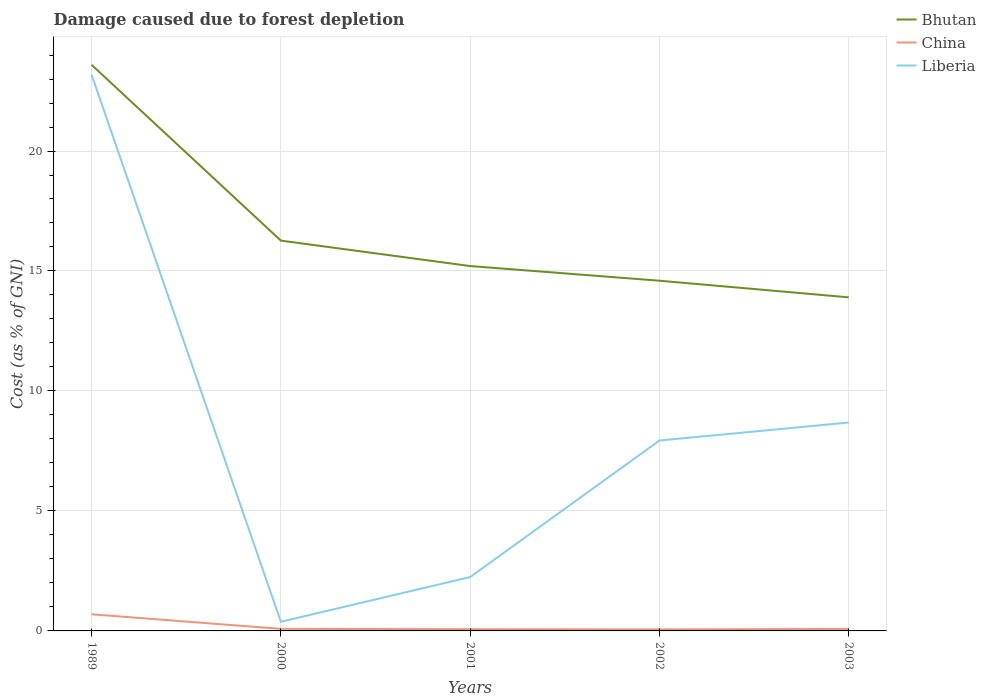Is the number of lines equal to the number of legend labels?
Keep it short and to the point. Yes. Across all years, what is the maximum cost of damage caused due to forest depletion in China?
Give a very brief answer. 0.06. What is the total cost of damage caused due to forest depletion in Liberia in the graph?
Your answer should be very brief. -0.75. What is the difference between the highest and the second highest cost of damage caused due to forest depletion in China?
Your answer should be compact. 0.63. How many lines are there?
Your answer should be very brief. 3. How many years are there in the graph?
Offer a terse response. 5. What is the difference between two consecutive major ticks on the Y-axis?
Provide a short and direct response. 5. Are the values on the major ticks of Y-axis written in scientific E-notation?
Your answer should be compact. No. Does the graph contain any zero values?
Ensure brevity in your answer.  No. How many legend labels are there?
Keep it short and to the point. 3. How are the legend labels stacked?
Provide a short and direct response. Vertical. What is the title of the graph?
Make the answer very short. Damage caused due to forest depletion. Does "Greece" appear as one of the legend labels in the graph?
Your response must be concise. No. What is the label or title of the Y-axis?
Your response must be concise. Cost (as % of GNI). What is the Cost (as % of GNI) in Bhutan in 1989?
Make the answer very short. 23.59. What is the Cost (as % of GNI) in China in 1989?
Make the answer very short. 0.69. What is the Cost (as % of GNI) in Liberia in 1989?
Your answer should be compact. 23.18. What is the Cost (as % of GNI) in Bhutan in 2000?
Provide a succinct answer. 16.27. What is the Cost (as % of GNI) in China in 2000?
Keep it short and to the point. 0.09. What is the Cost (as % of GNI) in Liberia in 2000?
Offer a very short reply. 0.38. What is the Cost (as % of GNI) of Bhutan in 2001?
Offer a very short reply. 15.21. What is the Cost (as % of GNI) of China in 2001?
Your response must be concise. 0.07. What is the Cost (as % of GNI) of Liberia in 2001?
Your answer should be compact. 2.24. What is the Cost (as % of GNI) of Bhutan in 2002?
Offer a very short reply. 14.59. What is the Cost (as % of GNI) of China in 2002?
Ensure brevity in your answer.  0.06. What is the Cost (as % of GNI) of Liberia in 2002?
Keep it short and to the point. 7.94. What is the Cost (as % of GNI) in Bhutan in 2003?
Make the answer very short. 13.9. What is the Cost (as % of GNI) in China in 2003?
Make the answer very short. 0.08. What is the Cost (as % of GNI) in Liberia in 2003?
Offer a very short reply. 8.68. Across all years, what is the maximum Cost (as % of GNI) in Bhutan?
Give a very brief answer. 23.59. Across all years, what is the maximum Cost (as % of GNI) in China?
Your answer should be compact. 0.69. Across all years, what is the maximum Cost (as % of GNI) of Liberia?
Give a very brief answer. 23.18. Across all years, what is the minimum Cost (as % of GNI) of Bhutan?
Offer a very short reply. 13.9. Across all years, what is the minimum Cost (as % of GNI) in China?
Give a very brief answer. 0.06. Across all years, what is the minimum Cost (as % of GNI) in Liberia?
Keep it short and to the point. 0.38. What is the total Cost (as % of GNI) of Bhutan in the graph?
Ensure brevity in your answer.  83.56. What is the total Cost (as % of GNI) in China in the graph?
Your answer should be very brief. 1. What is the total Cost (as % of GNI) in Liberia in the graph?
Your answer should be very brief. 42.43. What is the difference between the Cost (as % of GNI) of Bhutan in 1989 and that in 2000?
Your answer should be very brief. 7.33. What is the difference between the Cost (as % of GNI) in China in 1989 and that in 2000?
Your response must be concise. 0.61. What is the difference between the Cost (as % of GNI) of Liberia in 1989 and that in 2000?
Ensure brevity in your answer.  22.8. What is the difference between the Cost (as % of GNI) of Bhutan in 1989 and that in 2001?
Make the answer very short. 8.39. What is the difference between the Cost (as % of GNI) of China in 1989 and that in 2001?
Make the answer very short. 0.62. What is the difference between the Cost (as % of GNI) in Liberia in 1989 and that in 2001?
Offer a very short reply. 20.94. What is the difference between the Cost (as % of GNI) of Bhutan in 1989 and that in 2002?
Your answer should be compact. 9. What is the difference between the Cost (as % of GNI) in China in 1989 and that in 2002?
Offer a terse response. 0.63. What is the difference between the Cost (as % of GNI) in Liberia in 1989 and that in 2002?
Your response must be concise. 15.24. What is the difference between the Cost (as % of GNI) of Bhutan in 1989 and that in 2003?
Your answer should be very brief. 9.69. What is the difference between the Cost (as % of GNI) of China in 1989 and that in 2003?
Offer a terse response. 0.61. What is the difference between the Cost (as % of GNI) of Liberia in 1989 and that in 2003?
Give a very brief answer. 14.5. What is the difference between the Cost (as % of GNI) in Bhutan in 2000 and that in 2001?
Provide a succinct answer. 1.06. What is the difference between the Cost (as % of GNI) in China in 2000 and that in 2001?
Your response must be concise. 0.01. What is the difference between the Cost (as % of GNI) in Liberia in 2000 and that in 2001?
Provide a short and direct response. -1.86. What is the difference between the Cost (as % of GNI) of Bhutan in 2000 and that in 2002?
Your answer should be compact. 1.67. What is the difference between the Cost (as % of GNI) in China in 2000 and that in 2002?
Your answer should be very brief. 0.02. What is the difference between the Cost (as % of GNI) of Liberia in 2000 and that in 2002?
Your answer should be compact. -7.55. What is the difference between the Cost (as % of GNI) of Bhutan in 2000 and that in 2003?
Your response must be concise. 2.36. What is the difference between the Cost (as % of GNI) of China in 2000 and that in 2003?
Your answer should be compact. 0. What is the difference between the Cost (as % of GNI) in Liberia in 2000 and that in 2003?
Your answer should be compact. -8.3. What is the difference between the Cost (as % of GNI) in Bhutan in 2001 and that in 2002?
Provide a succinct answer. 0.61. What is the difference between the Cost (as % of GNI) of China in 2001 and that in 2002?
Provide a short and direct response. 0.01. What is the difference between the Cost (as % of GNI) in Liberia in 2001 and that in 2002?
Ensure brevity in your answer.  -5.69. What is the difference between the Cost (as % of GNI) of Bhutan in 2001 and that in 2003?
Your answer should be compact. 1.3. What is the difference between the Cost (as % of GNI) of China in 2001 and that in 2003?
Ensure brevity in your answer.  -0.01. What is the difference between the Cost (as % of GNI) in Liberia in 2001 and that in 2003?
Make the answer very short. -6.44. What is the difference between the Cost (as % of GNI) in Bhutan in 2002 and that in 2003?
Offer a very short reply. 0.69. What is the difference between the Cost (as % of GNI) of China in 2002 and that in 2003?
Keep it short and to the point. -0.02. What is the difference between the Cost (as % of GNI) of Liberia in 2002 and that in 2003?
Ensure brevity in your answer.  -0.75. What is the difference between the Cost (as % of GNI) in Bhutan in 1989 and the Cost (as % of GNI) in China in 2000?
Ensure brevity in your answer.  23.51. What is the difference between the Cost (as % of GNI) in Bhutan in 1989 and the Cost (as % of GNI) in Liberia in 2000?
Your response must be concise. 23.21. What is the difference between the Cost (as % of GNI) in China in 1989 and the Cost (as % of GNI) in Liberia in 2000?
Provide a short and direct response. 0.31. What is the difference between the Cost (as % of GNI) in Bhutan in 1989 and the Cost (as % of GNI) in China in 2001?
Your response must be concise. 23.52. What is the difference between the Cost (as % of GNI) in Bhutan in 1989 and the Cost (as % of GNI) in Liberia in 2001?
Give a very brief answer. 21.35. What is the difference between the Cost (as % of GNI) in China in 1989 and the Cost (as % of GNI) in Liberia in 2001?
Offer a very short reply. -1.55. What is the difference between the Cost (as % of GNI) of Bhutan in 1989 and the Cost (as % of GNI) of China in 2002?
Provide a short and direct response. 23.53. What is the difference between the Cost (as % of GNI) of Bhutan in 1989 and the Cost (as % of GNI) of Liberia in 2002?
Give a very brief answer. 15.66. What is the difference between the Cost (as % of GNI) in China in 1989 and the Cost (as % of GNI) in Liberia in 2002?
Your answer should be compact. -7.24. What is the difference between the Cost (as % of GNI) of Bhutan in 1989 and the Cost (as % of GNI) of China in 2003?
Provide a succinct answer. 23.51. What is the difference between the Cost (as % of GNI) in Bhutan in 1989 and the Cost (as % of GNI) in Liberia in 2003?
Offer a terse response. 14.91. What is the difference between the Cost (as % of GNI) in China in 1989 and the Cost (as % of GNI) in Liberia in 2003?
Keep it short and to the point. -7.99. What is the difference between the Cost (as % of GNI) of Bhutan in 2000 and the Cost (as % of GNI) of China in 2001?
Keep it short and to the point. 16.19. What is the difference between the Cost (as % of GNI) of Bhutan in 2000 and the Cost (as % of GNI) of Liberia in 2001?
Offer a terse response. 14.02. What is the difference between the Cost (as % of GNI) of China in 2000 and the Cost (as % of GNI) of Liberia in 2001?
Keep it short and to the point. -2.16. What is the difference between the Cost (as % of GNI) in Bhutan in 2000 and the Cost (as % of GNI) in China in 2002?
Make the answer very short. 16.2. What is the difference between the Cost (as % of GNI) in Bhutan in 2000 and the Cost (as % of GNI) in Liberia in 2002?
Make the answer very short. 8.33. What is the difference between the Cost (as % of GNI) of China in 2000 and the Cost (as % of GNI) of Liberia in 2002?
Offer a very short reply. -7.85. What is the difference between the Cost (as % of GNI) in Bhutan in 2000 and the Cost (as % of GNI) in China in 2003?
Your response must be concise. 16.18. What is the difference between the Cost (as % of GNI) in Bhutan in 2000 and the Cost (as % of GNI) in Liberia in 2003?
Keep it short and to the point. 7.58. What is the difference between the Cost (as % of GNI) of China in 2000 and the Cost (as % of GNI) of Liberia in 2003?
Your answer should be very brief. -8.6. What is the difference between the Cost (as % of GNI) of Bhutan in 2001 and the Cost (as % of GNI) of China in 2002?
Ensure brevity in your answer.  15.14. What is the difference between the Cost (as % of GNI) in Bhutan in 2001 and the Cost (as % of GNI) in Liberia in 2002?
Your answer should be very brief. 7.27. What is the difference between the Cost (as % of GNI) of China in 2001 and the Cost (as % of GNI) of Liberia in 2002?
Offer a very short reply. -7.86. What is the difference between the Cost (as % of GNI) in Bhutan in 2001 and the Cost (as % of GNI) in China in 2003?
Make the answer very short. 15.12. What is the difference between the Cost (as % of GNI) in Bhutan in 2001 and the Cost (as % of GNI) in Liberia in 2003?
Provide a short and direct response. 6.52. What is the difference between the Cost (as % of GNI) of China in 2001 and the Cost (as % of GNI) of Liberia in 2003?
Keep it short and to the point. -8.61. What is the difference between the Cost (as % of GNI) in Bhutan in 2002 and the Cost (as % of GNI) in China in 2003?
Your answer should be compact. 14.51. What is the difference between the Cost (as % of GNI) in Bhutan in 2002 and the Cost (as % of GNI) in Liberia in 2003?
Your response must be concise. 5.91. What is the difference between the Cost (as % of GNI) in China in 2002 and the Cost (as % of GNI) in Liberia in 2003?
Make the answer very short. -8.62. What is the average Cost (as % of GNI) of Bhutan per year?
Your response must be concise. 16.71. What is the average Cost (as % of GNI) in China per year?
Your answer should be very brief. 0.2. What is the average Cost (as % of GNI) in Liberia per year?
Ensure brevity in your answer.  8.49. In the year 1989, what is the difference between the Cost (as % of GNI) in Bhutan and Cost (as % of GNI) in China?
Keep it short and to the point. 22.9. In the year 1989, what is the difference between the Cost (as % of GNI) of Bhutan and Cost (as % of GNI) of Liberia?
Your answer should be very brief. 0.41. In the year 1989, what is the difference between the Cost (as % of GNI) in China and Cost (as % of GNI) in Liberia?
Your answer should be very brief. -22.49. In the year 2000, what is the difference between the Cost (as % of GNI) in Bhutan and Cost (as % of GNI) in China?
Keep it short and to the point. 16.18. In the year 2000, what is the difference between the Cost (as % of GNI) of Bhutan and Cost (as % of GNI) of Liberia?
Make the answer very short. 15.88. In the year 2000, what is the difference between the Cost (as % of GNI) of China and Cost (as % of GNI) of Liberia?
Provide a succinct answer. -0.3. In the year 2001, what is the difference between the Cost (as % of GNI) in Bhutan and Cost (as % of GNI) in China?
Provide a succinct answer. 15.13. In the year 2001, what is the difference between the Cost (as % of GNI) of Bhutan and Cost (as % of GNI) of Liberia?
Keep it short and to the point. 12.96. In the year 2001, what is the difference between the Cost (as % of GNI) in China and Cost (as % of GNI) in Liberia?
Offer a very short reply. -2.17. In the year 2002, what is the difference between the Cost (as % of GNI) of Bhutan and Cost (as % of GNI) of China?
Ensure brevity in your answer.  14.53. In the year 2002, what is the difference between the Cost (as % of GNI) of Bhutan and Cost (as % of GNI) of Liberia?
Keep it short and to the point. 6.66. In the year 2002, what is the difference between the Cost (as % of GNI) in China and Cost (as % of GNI) in Liberia?
Provide a short and direct response. -7.87. In the year 2003, what is the difference between the Cost (as % of GNI) in Bhutan and Cost (as % of GNI) in China?
Make the answer very short. 13.82. In the year 2003, what is the difference between the Cost (as % of GNI) in Bhutan and Cost (as % of GNI) in Liberia?
Ensure brevity in your answer.  5.22. In the year 2003, what is the difference between the Cost (as % of GNI) of China and Cost (as % of GNI) of Liberia?
Your answer should be compact. -8.6. What is the ratio of the Cost (as % of GNI) in Bhutan in 1989 to that in 2000?
Give a very brief answer. 1.45. What is the ratio of the Cost (as % of GNI) in China in 1989 to that in 2000?
Your response must be concise. 8.14. What is the ratio of the Cost (as % of GNI) of Liberia in 1989 to that in 2000?
Provide a short and direct response. 60.8. What is the ratio of the Cost (as % of GNI) in Bhutan in 1989 to that in 2001?
Provide a short and direct response. 1.55. What is the ratio of the Cost (as % of GNI) of China in 1989 to that in 2001?
Ensure brevity in your answer.  9.49. What is the ratio of the Cost (as % of GNI) of Liberia in 1989 to that in 2001?
Keep it short and to the point. 10.33. What is the ratio of the Cost (as % of GNI) in Bhutan in 1989 to that in 2002?
Your answer should be compact. 1.62. What is the ratio of the Cost (as % of GNI) of China in 1989 to that in 2002?
Ensure brevity in your answer.  10.69. What is the ratio of the Cost (as % of GNI) in Liberia in 1989 to that in 2002?
Ensure brevity in your answer.  2.92. What is the ratio of the Cost (as % of GNI) of Bhutan in 1989 to that in 2003?
Your answer should be compact. 1.7. What is the ratio of the Cost (as % of GNI) of China in 1989 to that in 2003?
Keep it short and to the point. 8.48. What is the ratio of the Cost (as % of GNI) of Liberia in 1989 to that in 2003?
Your answer should be very brief. 2.67. What is the ratio of the Cost (as % of GNI) in Bhutan in 2000 to that in 2001?
Provide a short and direct response. 1.07. What is the ratio of the Cost (as % of GNI) in China in 2000 to that in 2001?
Provide a short and direct response. 1.17. What is the ratio of the Cost (as % of GNI) in Liberia in 2000 to that in 2001?
Provide a succinct answer. 0.17. What is the ratio of the Cost (as % of GNI) of Bhutan in 2000 to that in 2002?
Make the answer very short. 1.11. What is the ratio of the Cost (as % of GNI) in China in 2000 to that in 2002?
Your response must be concise. 1.31. What is the ratio of the Cost (as % of GNI) of Liberia in 2000 to that in 2002?
Provide a short and direct response. 0.05. What is the ratio of the Cost (as % of GNI) of Bhutan in 2000 to that in 2003?
Offer a terse response. 1.17. What is the ratio of the Cost (as % of GNI) of China in 2000 to that in 2003?
Make the answer very short. 1.04. What is the ratio of the Cost (as % of GNI) in Liberia in 2000 to that in 2003?
Ensure brevity in your answer.  0.04. What is the ratio of the Cost (as % of GNI) in Bhutan in 2001 to that in 2002?
Make the answer very short. 1.04. What is the ratio of the Cost (as % of GNI) of China in 2001 to that in 2002?
Offer a terse response. 1.13. What is the ratio of the Cost (as % of GNI) in Liberia in 2001 to that in 2002?
Your answer should be compact. 0.28. What is the ratio of the Cost (as % of GNI) of Bhutan in 2001 to that in 2003?
Keep it short and to the point. 1.09. What is the ratio of the Cost (as % of GNI) of China in 2001 to that in 2003?
Provide a short and direct response. 0.89. What is the ratio of the Cost (as % of GNI) of Liberia in 2001 to that in 2003?
Provide a succinct answer. 0.26. What is the ratio of the Cost (as % of GNI) in Bhutan in 2002 to that in 2003?
Make the answer very short. 1.05. What is the ratio of the Cost (as % of GNI) in China in 2002 to that in 2003?
Make the answer very short. 0.79. What is the ratio of the Cost (as % of GNI) of Liberia in 2002 to that in 2003?
Give a very brief answer. 0.91. What is the difference between the highest and the second highest Cost (as % of GNI) of Bhutan?
Provide a succinct answer. 7.33. What is the difference between the highest and the second highest Cost (as % of GNI) of China?
Provide a succinct answer. 0.61. What is the difference between the highest and the second highest Cost (as % of GNI) in Liberia?
Your answer should be very brief. 14.5. What is the difference between the highest and the lowest Cost (as % of GNI) in Bhutan?
Your answer should be compact. 9.69. What is the difference between the highest and the lowest Cost (as % of GNI) of China?
Provide a succinct answer. 0.63. What is the difference between the highest and the lowest Cost (as % of GNI) of Liberia?
Make the answer very short. 22.8. 